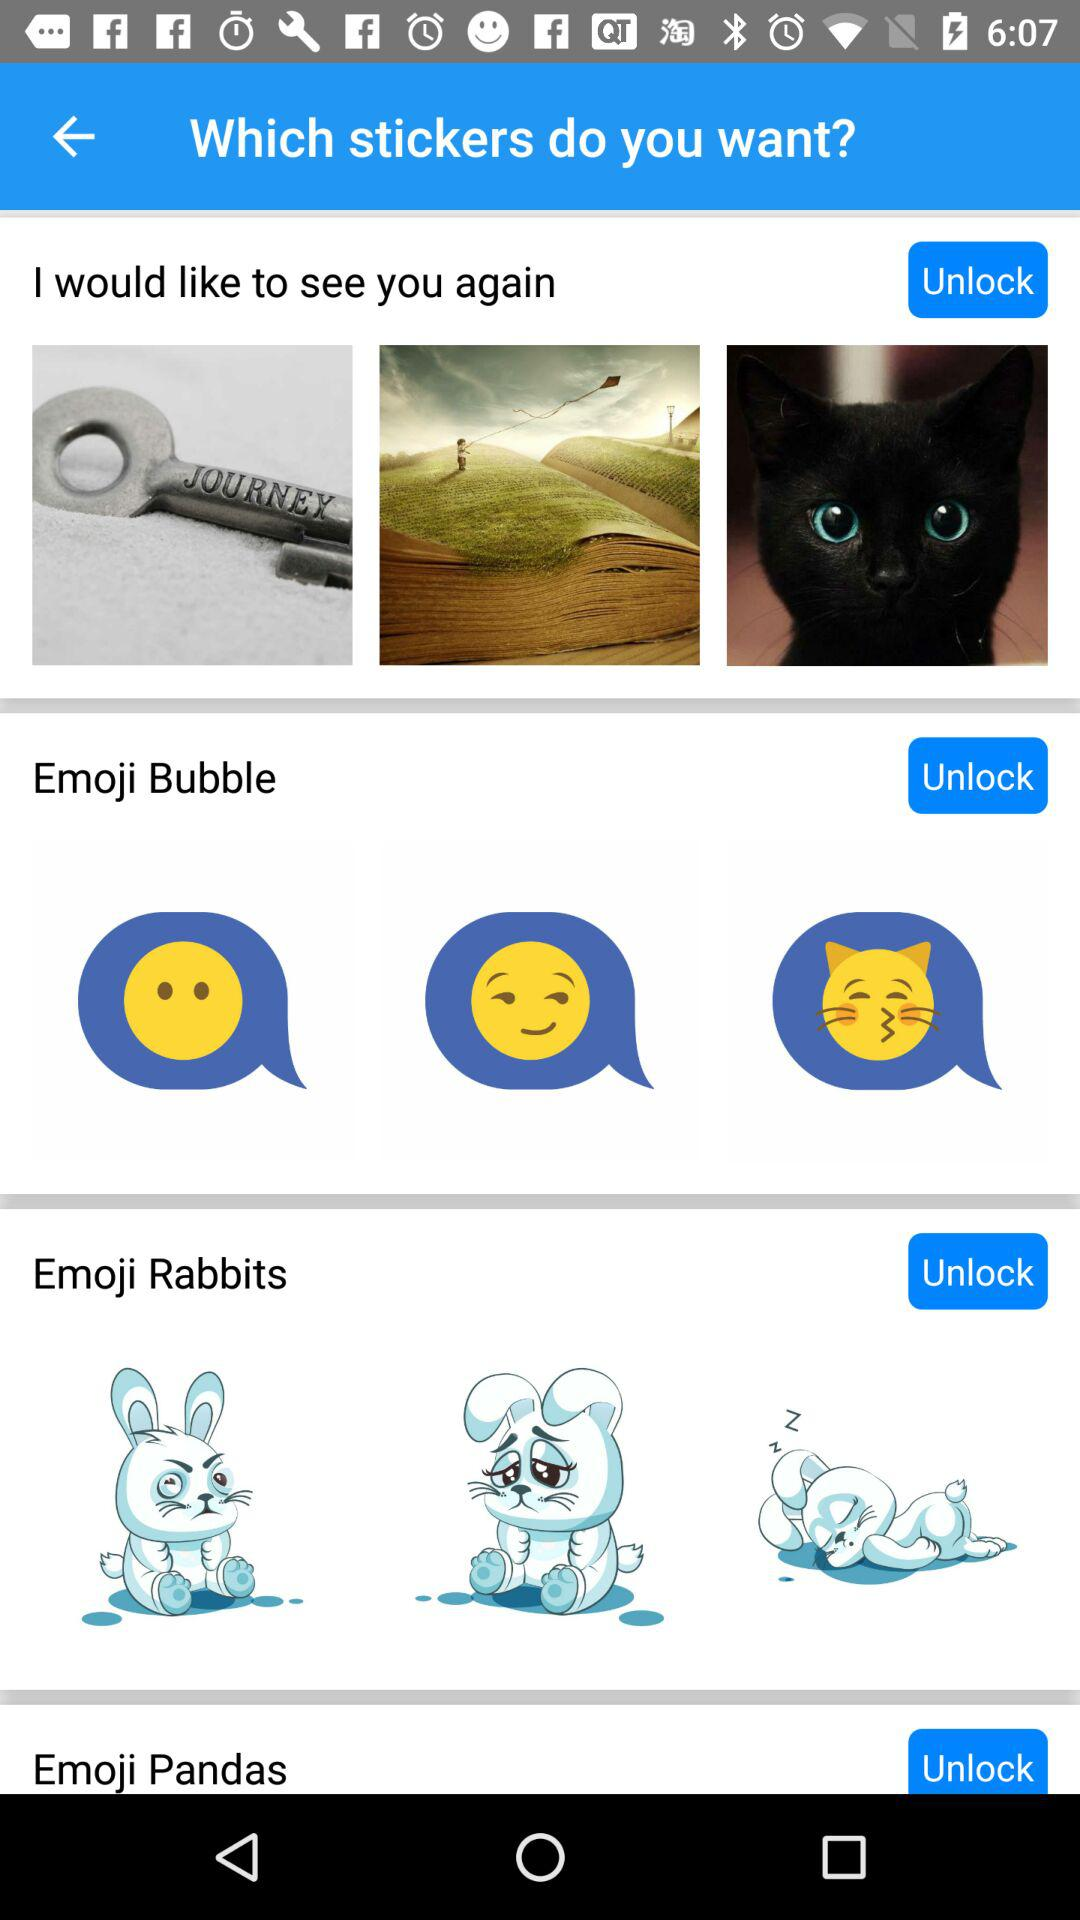What are the names of the stickers available on the screen? The available stickers are "I would like to see you again", "Emoji Bubble", "Emoji Rabbits" and "Emoji Pandas". 